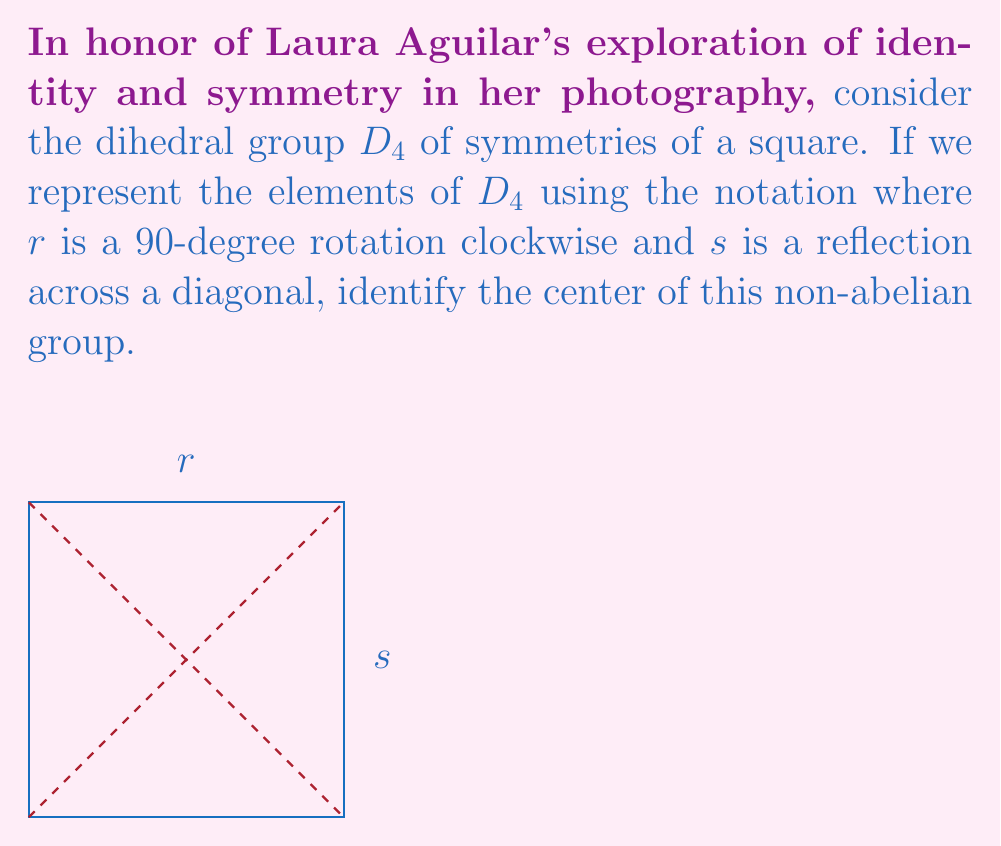Give your solution to this math problem. To find the center of $D_4$, we need to identify all elements that commute with every other element in the group.

1) First, let's list all elements of $D_4$:
   $\{e, r, r^2, r^3, s, sr, sr^2, sr^3\}$

2) The identity element $e$ always commutes with all elements, so it's in the center.

3) For rotations:
   - $r$ doesn't commute with reflections (e.g., $rs \neq sr$)
   - $r^3$ doesn't commute with reflections for the same reason
   - $r^2$ (180-degree rotation) commutes with all elements:
     $r^2r = rr^2$, $r^2s = sr^2$, etc.

4) For reflections:
   - $s$, $sr$, $sr^2$, $sr^3$ don't commute with rotations

5) Therefore, the center consists of $\{e, r^2\}$

This result aligns with the idea that the 180-degree rotation (like the identity) preserves the overall symmetry of the square, regardless of which reflections or rotations are applied before or after it.
Answer: $Z(D_4) = \{e, r^2\}$ 